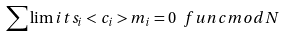Convert formula to latex. <formula><loc_0><loc_0><loc_500><loc_500>\sum \lim i t s _ { i } < c _ { i } > m _ { i } = 0 \ f u n c { m o d } N</formula> 